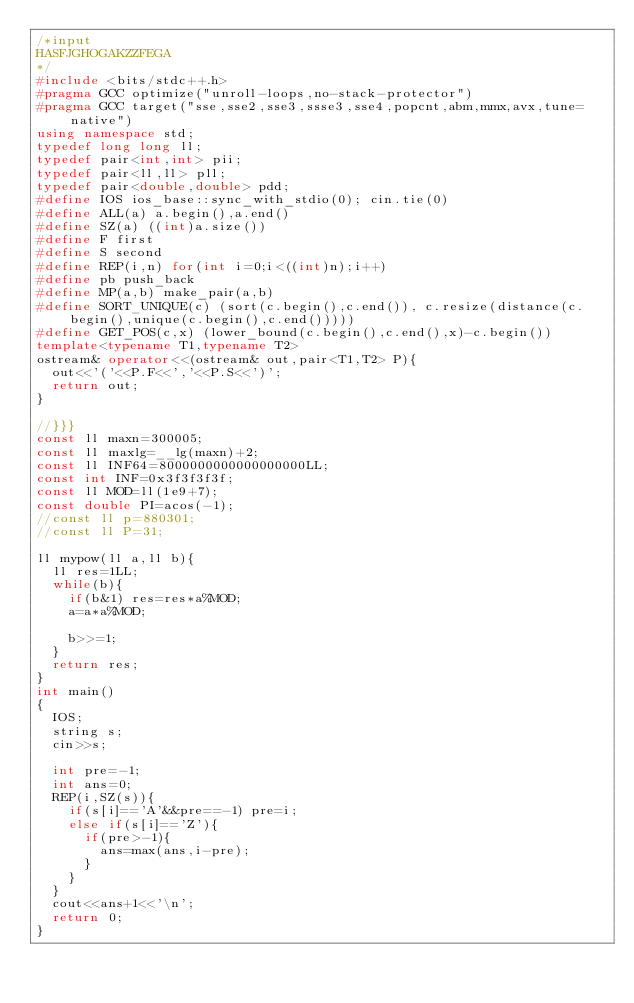<code> <loc_0><loc_0><loc_500><loc_500><_C++_>/*input
HASFJGHOGAKZZFEGA
*/
#include <bits/stdc++.h>
#pragma GCC optimize("unroll-loops,no-stack-protector")
#pragma GCC target("sse,sse2,sse3,ssse3,sse4,popcnt,abm,mmx,avx,tune=native")
using namespace std;
typedef long long ll;
typedef pair<int,int> pii;
typedef pair<ll,ll> pll;
typedef pair<double,double> pdd;
#define IOS ios_base::sync_with_stdio(0); cin.tie(0)
#define ALL(a) a.begin(),a.end()
#define SZ(a) ((int)a.size())
#define F first
#define S second
#define REP(i,n) for(int i=0;i<((int)n);i++)
#define pb push_back
#define MP(a,b) make_pair(a,b)
#define SORT_UNIQUE(c) (sort(c.begin(),c.end()), c.resize(distance(c.begin(),unique(c.begin(),c.end()))))
#define GET_POS(c,x) (lower_bound(c.begin(),c.end(),x)-c.begin())
template<typename T1,typename T2>
ostream& operator<<(ostream& out,pair<T1,T2> P){
	out<<'('<<P.F<<','<<P.S<<')';
	return out;
}

//}}}
const ll maxn=300005;
const ll maxlg=__lg(maxn)+2;
const ll INF64=8000000000000000000LL;
const int INF=0x3f3f3f3f;
const ll MOD=ll(1e9+7);
const double PI=acos(-1);
//const ll p=880301;
//const ll P=31;

ll mypow(ll a,ll b){
	ll res=1LL;
	while(b){
		if(b&1) res=res*a%MOD;
		a=a*a%MOD;
		
		b>>=1;
	}
	return res;
}
int main()
{
	IOS;
	string s;
	cin>>s;

	int pre=-1;
	int ans=0;
	REP(i,SZ(s)){
		if(s[i]=='A'&&pre==-1) pre=i;
		else if(s[i]=='Z'){
			if(pre>-1){
				ans=max(ans,i-pre);
			}
		}
	}
	cout<<ans+1<<'\n';
	return 0;
}
</code> 